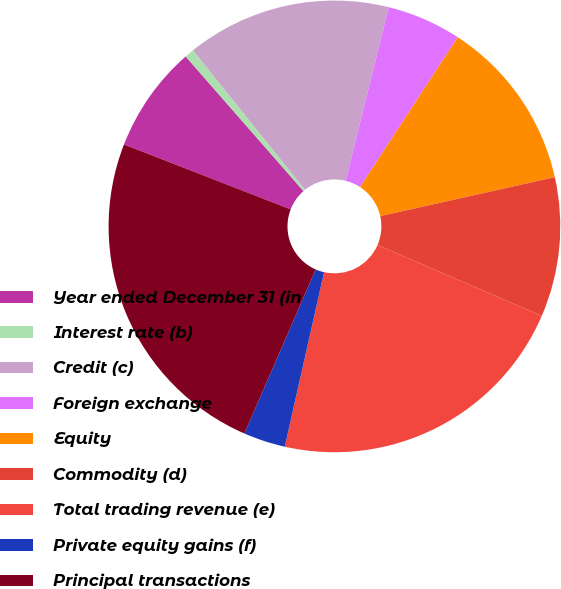<chart> <loc_0><loc_0><loc_500><loc_500><pie_chart><fcel>Year ended December 31 (in<fcel>Interest rate (b)<fcel>Credit (c)<fcel>Foreign exchange<fcel>Equity<fcel>Commodity (d)<fcel>Total trading revenue (e)<fcel>Private equity gains (f)<fcel>Principal transactions<nl><fcel>7.65%<fcel>0.67%<fcel>14.64%<fcel>5.33%<fcel>12.31%<fcel>9.98%<fcel>22.05%<fcel>3.0%<fcel>24.38%<nl></chart> 